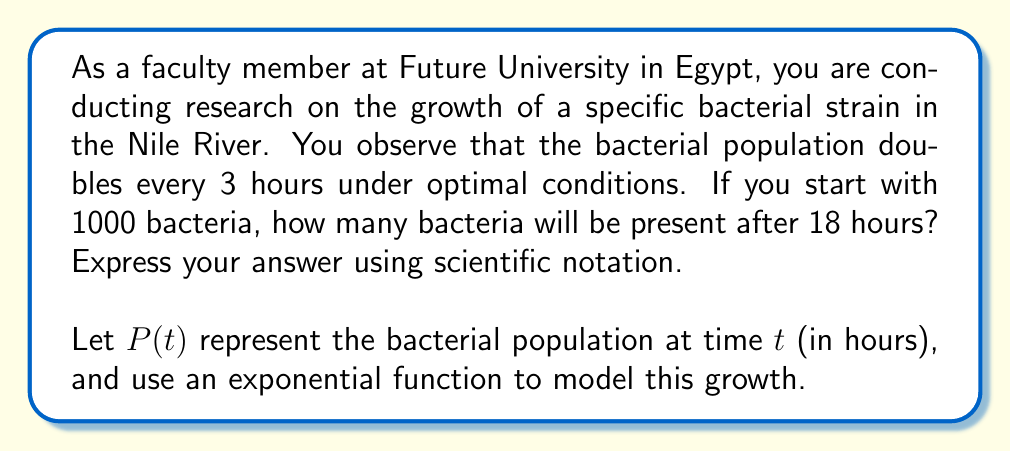Could you help me with this problem? To solve this problem, we'll use an exponential growth model:

1) The general form of an exponential growth function is:
   $$P(t) = P_0 \cdot b^t$$
   where $P_0$ is the initial population, $b$ is the growth factor, and $t$ is time.

2) We're given:
   - Initial population, $P_0 = 1000$
   - The population doubles every 3 hours
   - We need to find the population after 18 hours

3) To find $b$, we use the doubling time:
   $$2 = b^3$$
   $$b = 2^{\frac{1}{3}} \approx 1.2599$$

4) Now we can write our function:
   $$P(t) = 1000 \cdot (2^{\frac{1}{3}})^t$$

5) To find the population after 18 hours, we substitute $t = 18$:
   $$P(18) = 1000 \cdot (2^{\frac{1}{3}})^{18}$$

6) Simplify:
   $$P(18) = 1000 \cdot 2^6 = 1000 \cdot 64 = 64000$$

7) Express in scientific notation:
   $$P(18) = 6.4 \times 10^4$$
Answer: $6.4 \times 10^4$ bacteria 